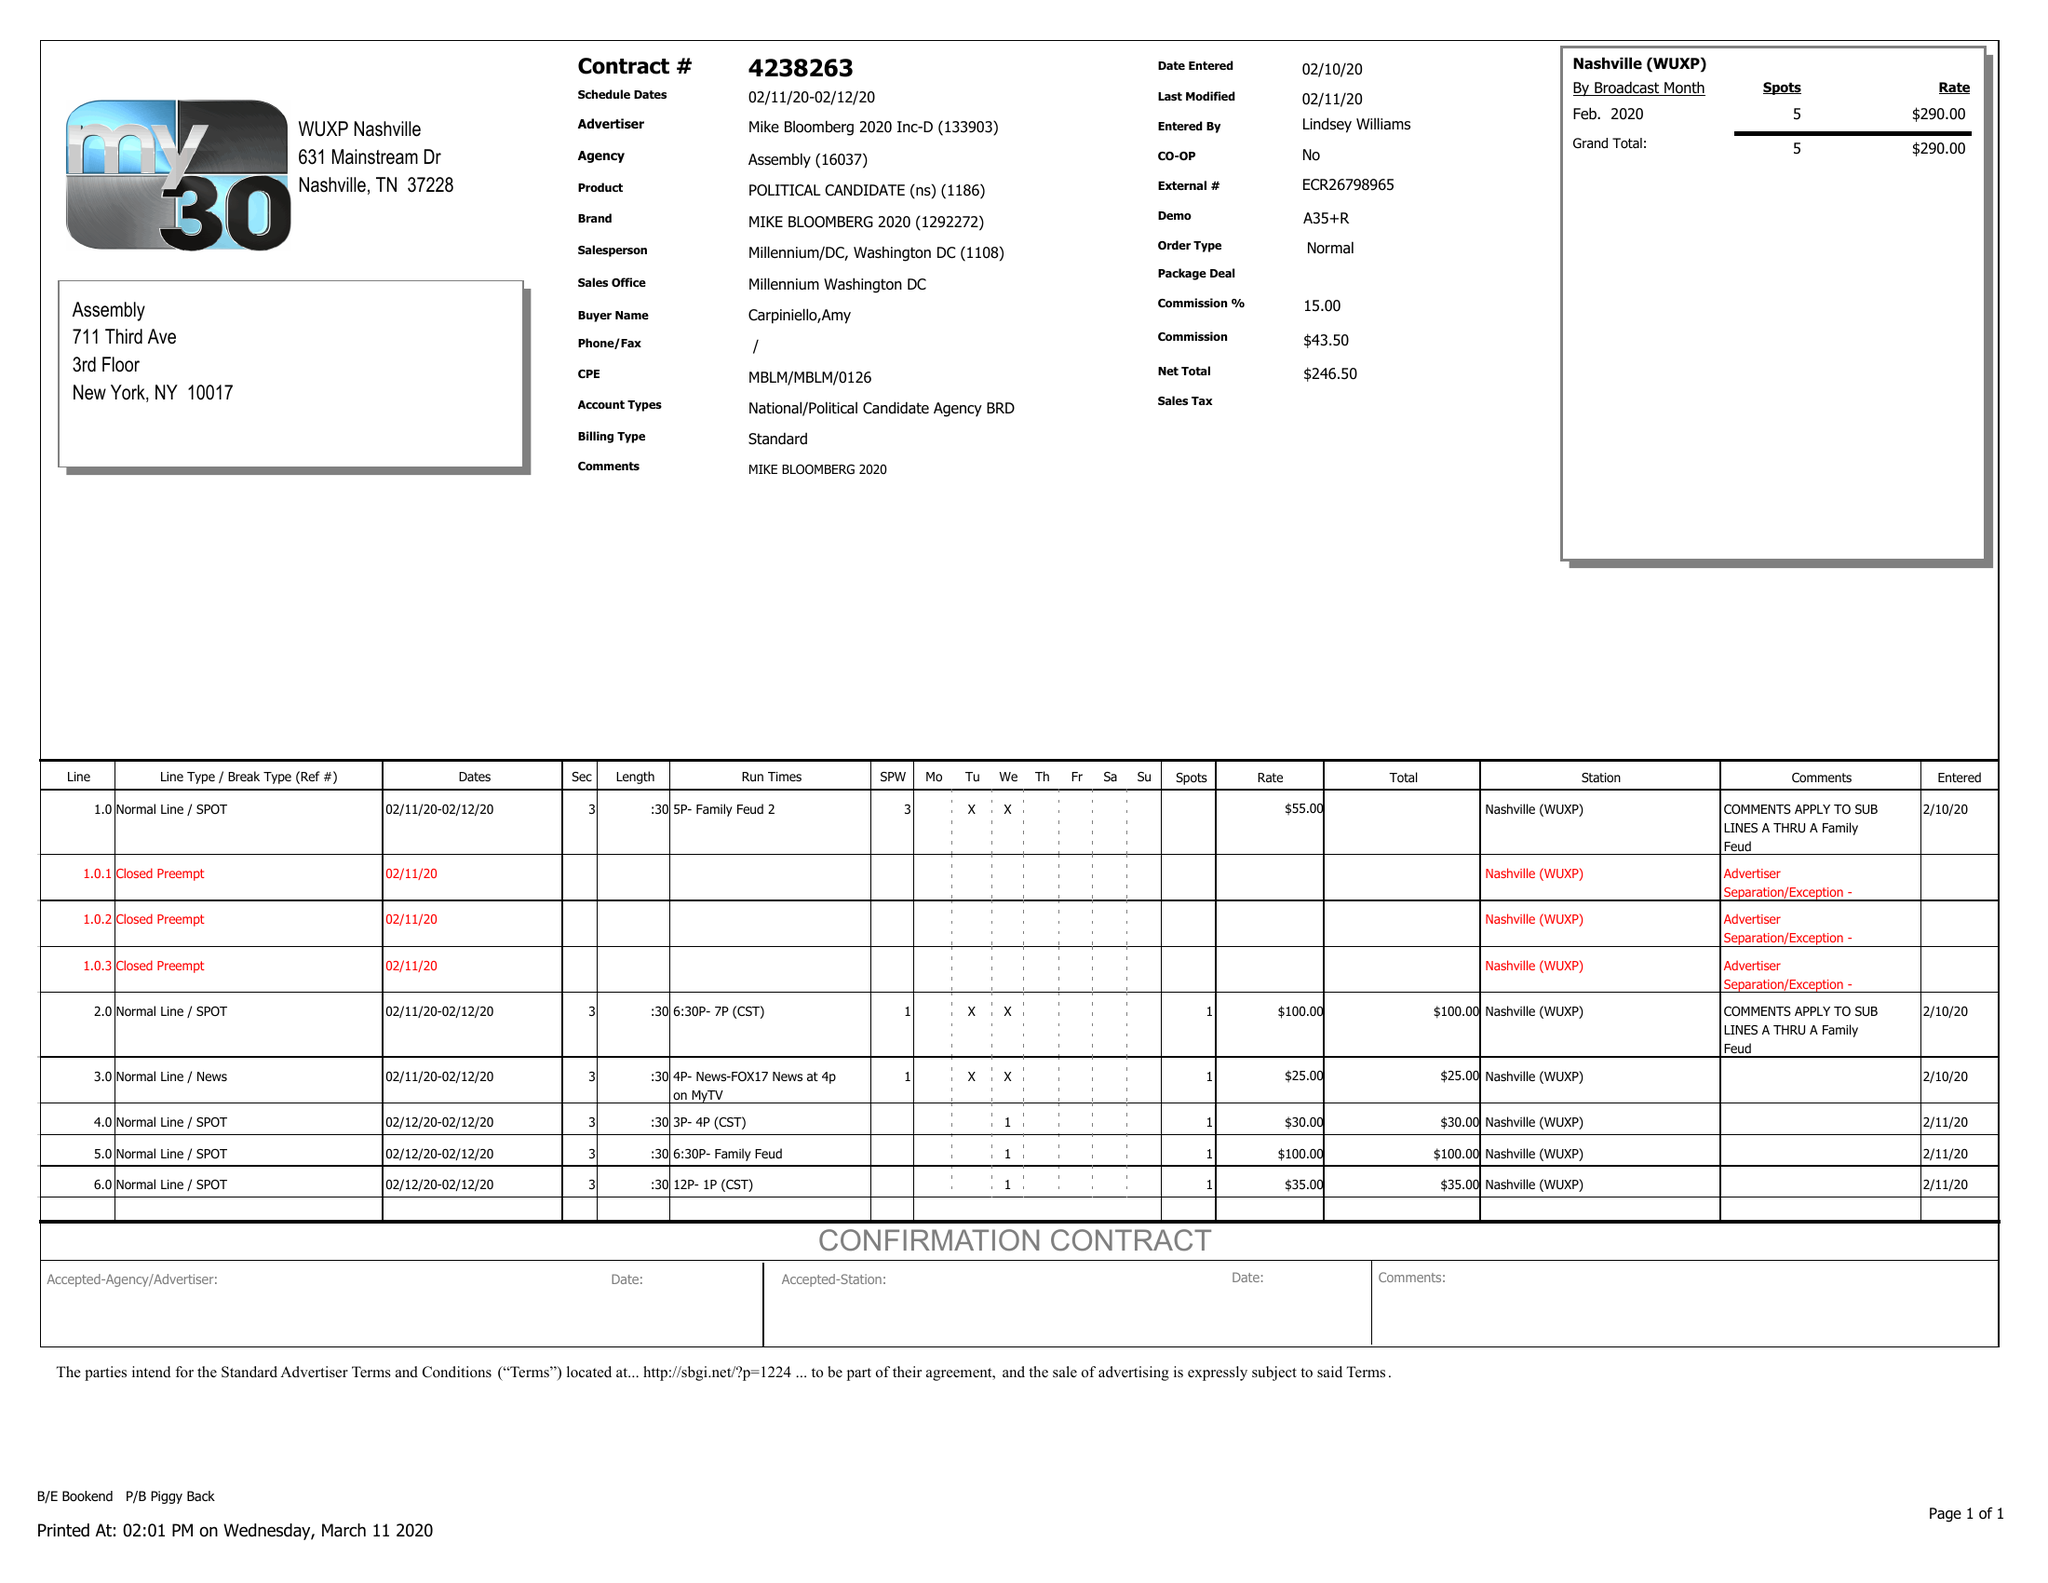What is the value for the advertiser?
Answer the question using a single word or phrase. MIKE BLOOMBERG 2020 INC-D 